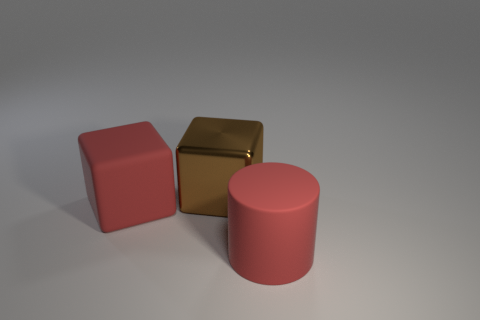Add 2 red things. How many objects exist? 5 Subtract all cylinders. How many objects are left? 2 Add 3 brown cubes. How many brown cubes exist? 4 Subtract 0 green spheres. How many objects are left? 3 Subtract all large cylinders. Subtract all big brown objects. How many objects are left? 1 Add 1 brown metal cubes. How many brown metal cubes are left? 2 